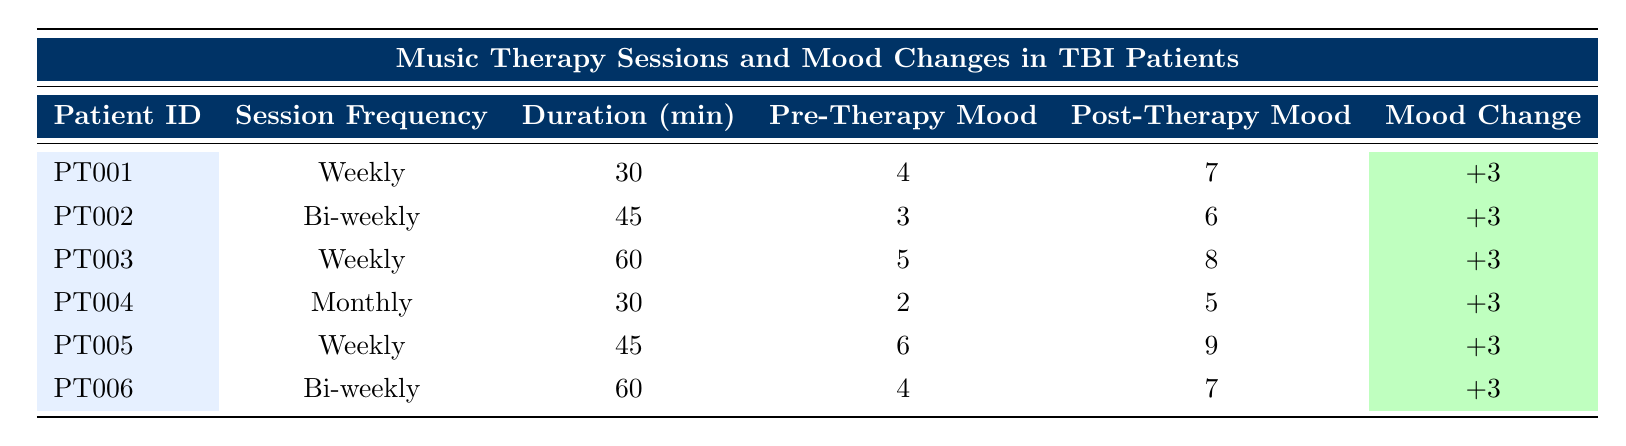What is the session frequency for patient PT001? In the table, under the column "Session Frequency," the row corresponding to patient PT001 lists "Weekly." Therefore, this is the session frequency for this patient.
Answer: Weekly What is the mood change score for patient PT003? The mood change score for patient PT003 can be found in the "Mood Change" column. It lists "+3," indicating the change in mood after the therapy session.
Answer: +3 Which patients had bi-weekly music therapy sessions? To identify the patients with bi-weekly music therapy sessions, we can look under the "Session Frequency" column. There are two patients listed with "Bi-weekly" sessions: PT002 and PT006.
Answer: PT002, PT006 What is the average session duration for all patients? To calculate the average session duration, we first add together all the session durations: 30 + 45 + 60 + 30 + 45 + 60 = 270 minutes. There are 6 patients, thus we divide 270 by 6. The average duration is 270/6 = 45 minutes.
Answer: 45 minutes Did any patient have a pre-therapy mood score of 6? Looking through the "Pre-Therapy Mood" column, we find that patient PT005 has a pre-therapy mood score of 6. Hence, the fact is true.
Answer: Yes What is the maximum post-therapy mood score across all patients? To find the maximum post-therapy mood score, we look at the "Post-Therapy Mood" column and identify the highest score. The scores are: 7, 6, 8, 5, 9, 7. The highest score is 9 from patient PT005.
Answer: 9 How many patients showed a mood change of +3? Checking the "Mood Change" column, all patients (PT001, PT002, PT003, PT004, PT005, PT006) show a mood change of +3. Therefore, the number of patients is 6.
Answer: 6 Was the pre-therapy mood score for any patient lower than 3? In the "Pre-Therapy Mood" column, PT002 has a score of 3, and PT004 has a score of 2, meaning there are patients below 3. Thus, the answer is yes.
Answer: Yes 